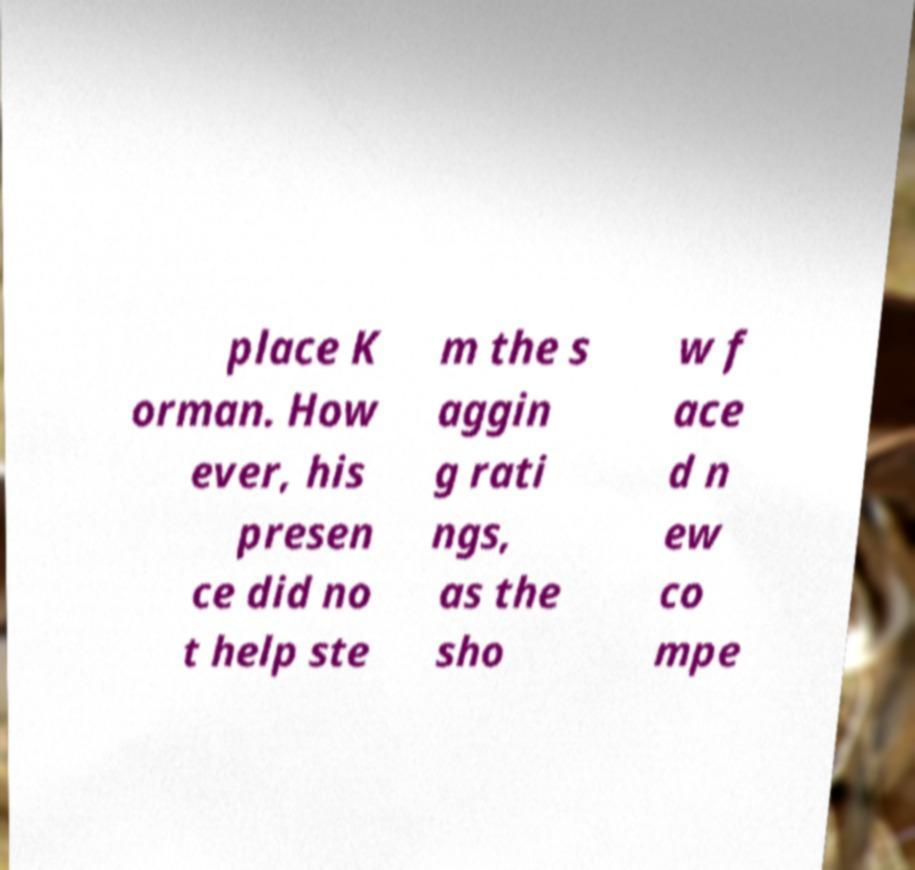Can you read and provide the text displayed in the image?This photo seems to have some interesting text. Can you extract and type it out for me? place K orman. How ever, his presen ce did no t help ste m the s aggin g rati ngs, as the sho w f ace d n ew co mpe 